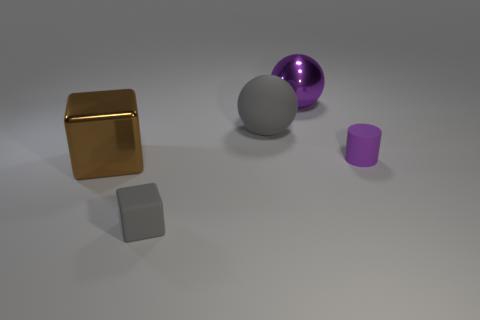Add 2 big yellow spheres. How many objects exist? 7 Subtract all spheres. How many objects are left? 3 Subtract 0 blue balls. How many objects are left? 5 Subtract all large blue matte objects. Subtract all gray blocks. How many objects are left? 4 Add 5 brown cubes. How many brown cubes are left? 6 Add 5 tiny matte spheres. How many tiny matte spheres exist? 5 